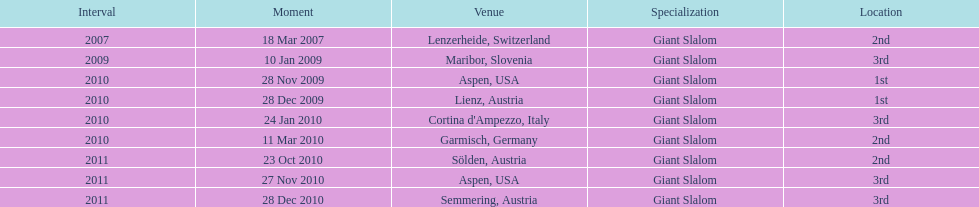What was the finishing place of the last race in december 2010? 3rd. 